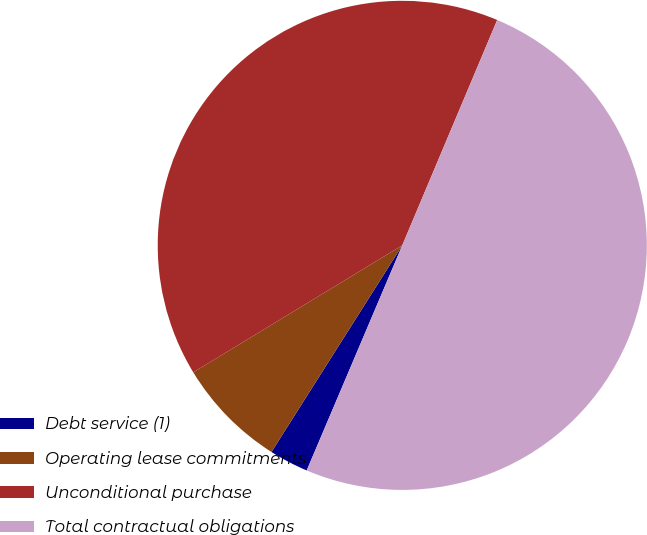Convert chart. <chart><loc_0><loc_0><loc_500><loc_500><pie_chart><fcel>Debt service (1)<fcel>Operating lease commitments<fcel>Unconditional purchase<fcel>Total contractual obligations<nl><fcel>2.59%<fcel>7.33%<fcel>40.04%<fcel>50.05%<nl></chart> 